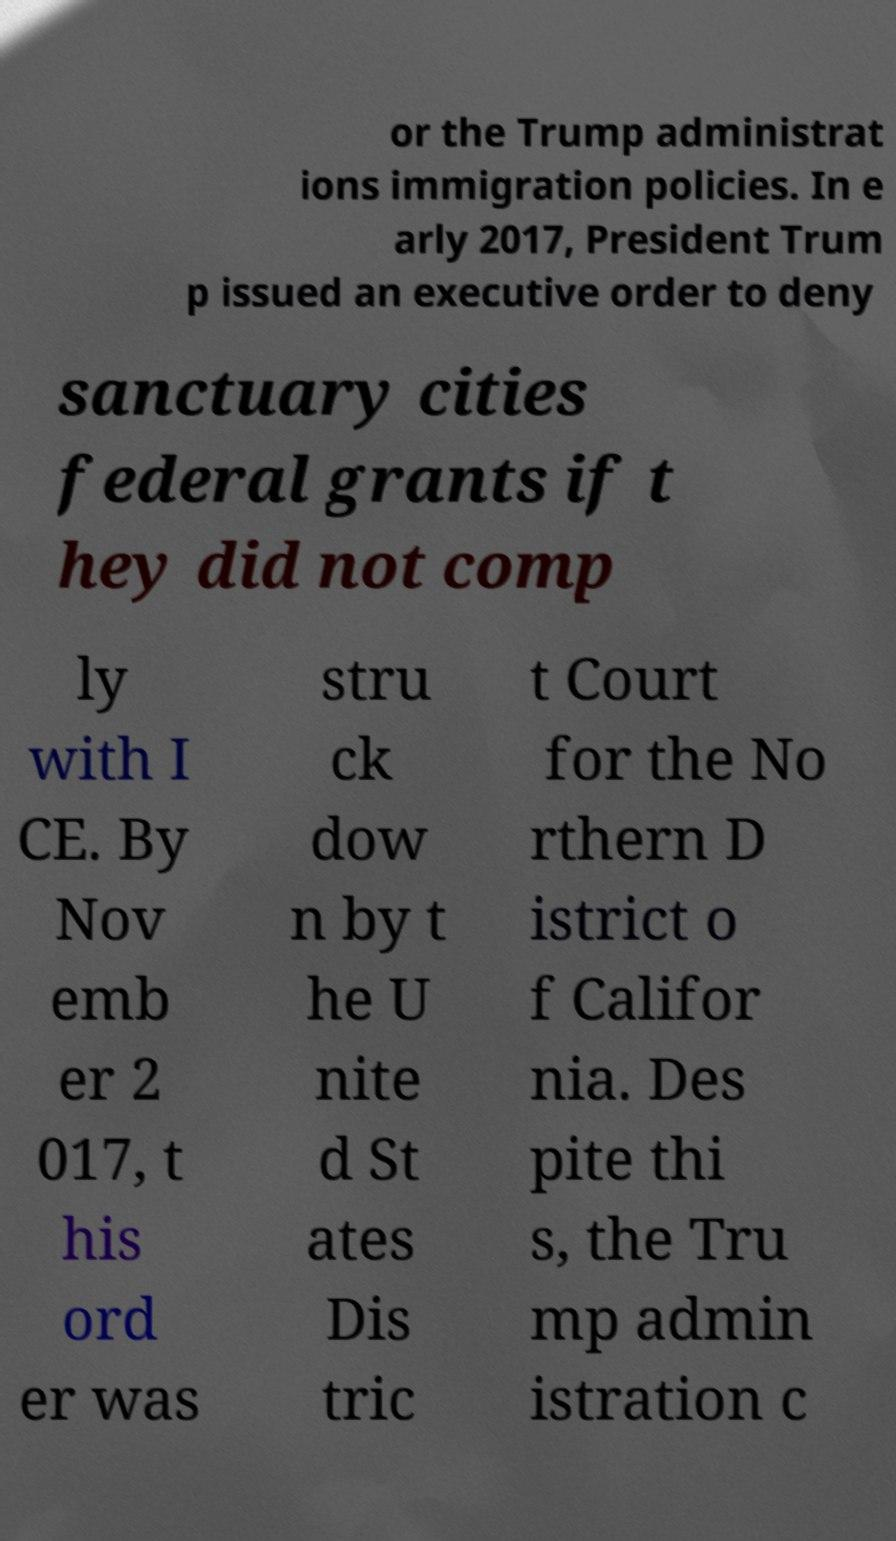I need the written content from this picture converted into text. Can you do that? or the Trump administrat ions immigration policies. In e arly 2017, President Trum p issued an executive order to deny sanctuary cities federal grants if t hey did not comp ly with I CE. By Nov emb er 2 017, t his ord er was stru ck dow n by t he U nite d St ates Dis tric t Court for the No rthern D istrict o f Califor nia. Des pite thi s, the Tru mp admin istration c 